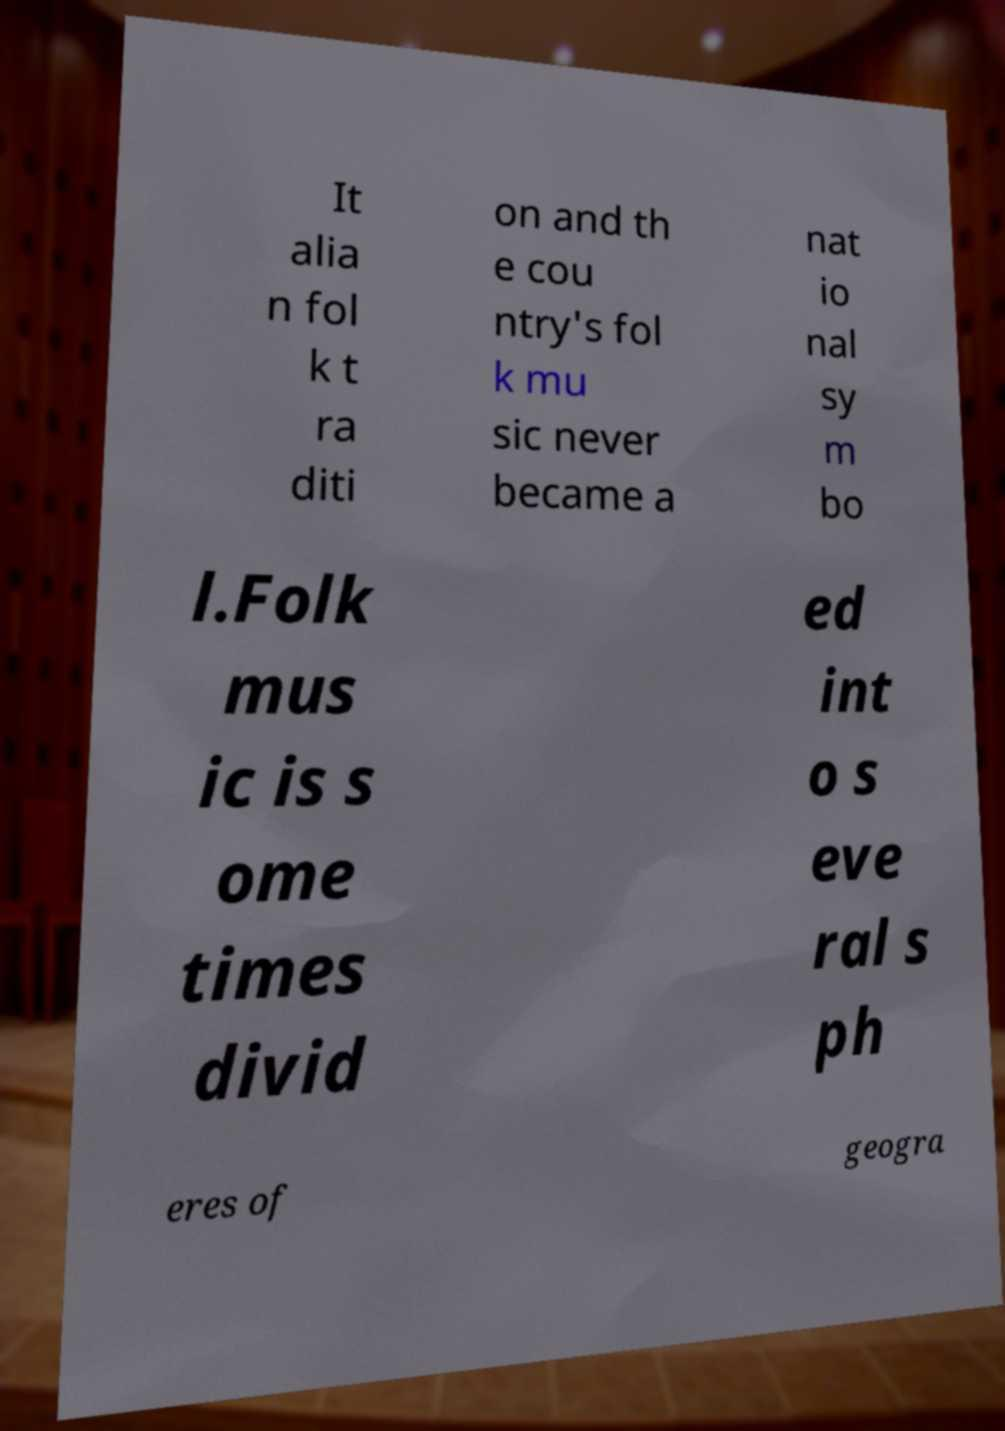Can you accurately transcribe the text from the provided image for me? It alia n fol k t ra diti on and th e cou ntry's fol k mu sic never became a nat io nal sy m bo l.Folk mus ic is s ome times divid ed int o s eve ral s ph eres of geogra 